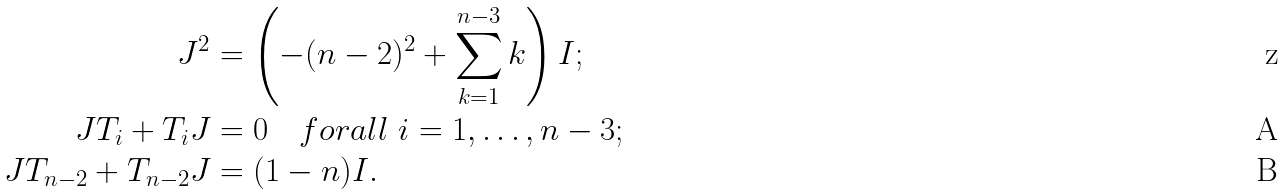Convert formula to latex. <formula><loc_0><loc_0><loc_500><loc_500>J ^ { 2 } & = \left ( - ( n - 2 ) ^ { 2 } + \sum _ { k = 1 } ^ { n - 3 } k \right ) I ; \\ J T _ { i } + T _ { i } J & = 0 \quad f o r a l l \ i = 1 , \dots , n - 3 ; \\ J T _ { n - 2 } + T _ { n - 2 } J & = ( 1 - n ) I .</formula> 